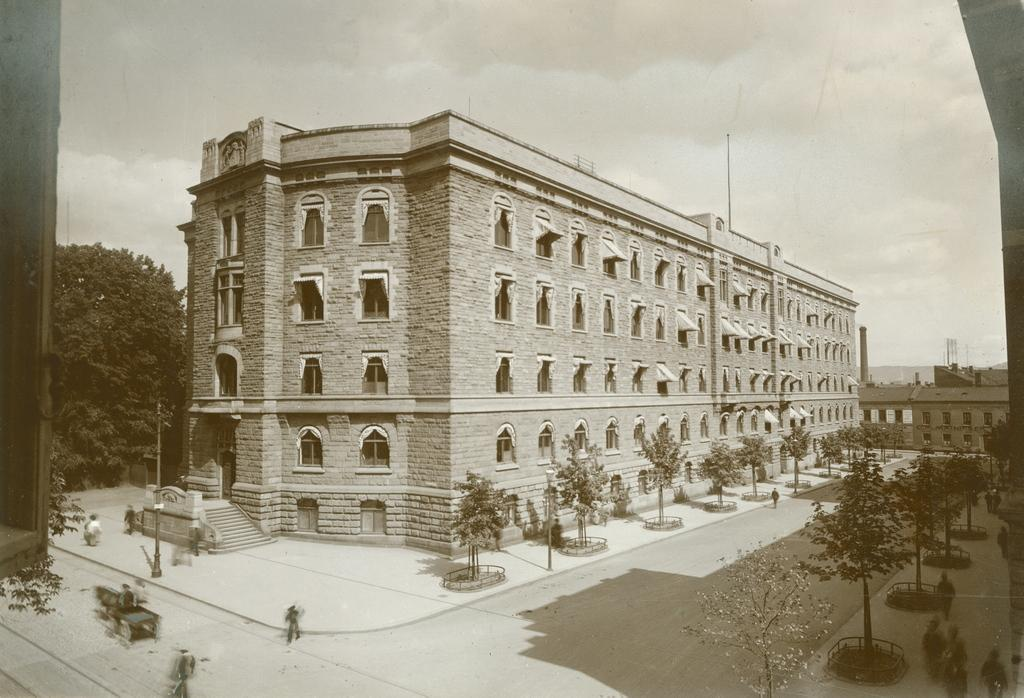What can be seen on the ground in the image? There are people on the ground in the image. What type of structures are present in the image? There are buildings in the image. What type of vegetation is visible in the image? There are trees in the image. What type of infrastructure is present in the image? There are electric poles in the image. What else can be seen in the image besides the mentioned elements? There are some unspecified objects in the image. What is visible in the background of the image? The sky is visible in the background of the image. Are there any farm animals visible in the image? There is no mention of farm animals in the provided facts, so we cannot determine their presence in the image. What type of ball is being used by the people in the image? There is no ball present in the image, as mentioned in the provided facts. 